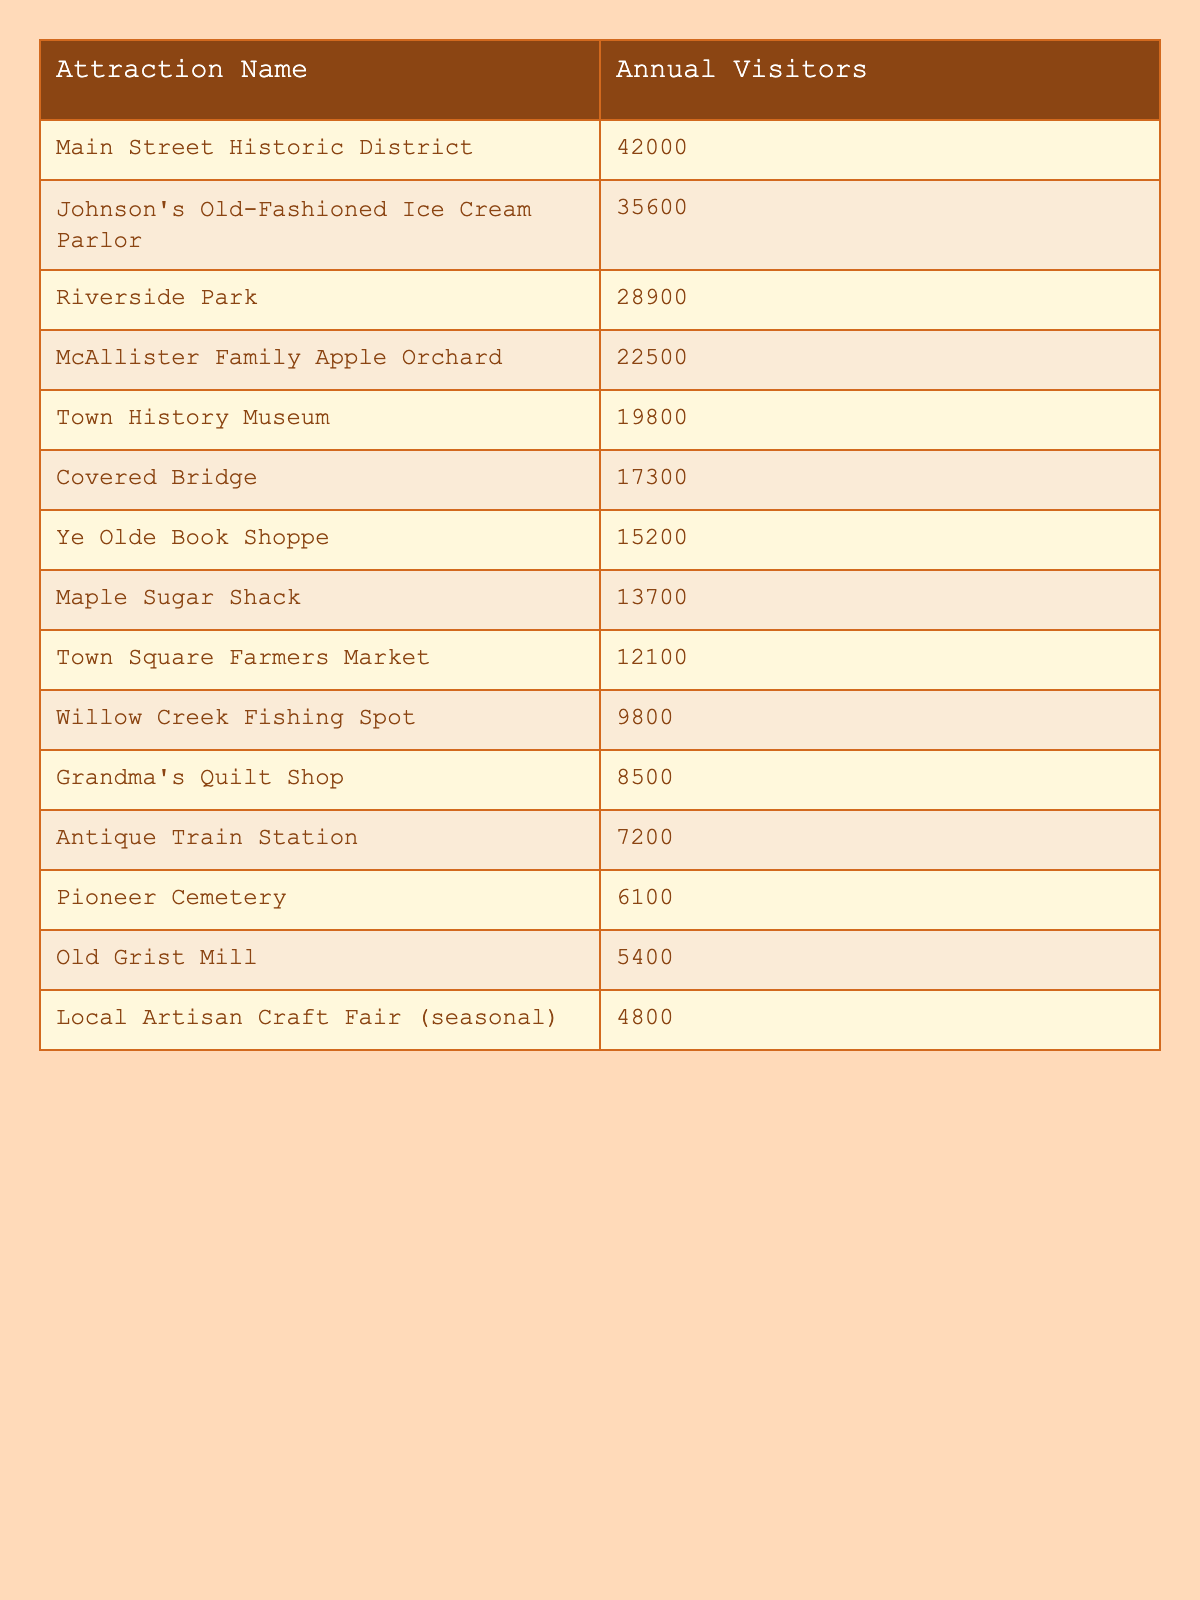What is the attraction with the highest annual visitors? By looking at the table, the "Main Street Historic District" has the highest number of visitors, with 42,000 recorded annually.
Answer: Main Street Historic District How many visitors does the Town History Museum have? The table lists the "Town History Museum" with an annual visitor count of 19,800.
Answer: 19800 What is the total number of visitors for the top three attractions? To find the total, we add the annual visitors of the top three attractions: 42,000 (Main Street) + 35,600 (Johnson's Old-Fashioned Ice Cream Parlor) + 28,900 (Riverside Park) = 113,500.
Answer: 113500 Is the Covered Bridge more popular than Grandma's Quilt Shop? The table shows that the Covered Bridge has 17,300 visitors while Grandma's Quilt Shop has 8,500 visitors, thus the Covered Bridge is more popular.
Answer: Yes What is the difference in visitor counts between the McAllister Family Apple Orchard and the Antique Train Station? The McAllister Family Apple Orchard has 22,500 visitors and the Antique Train Station has 7,200 visitors. The difference is 22,500 - 7,200 = 15,300.
Answer: 15300 What is the average number of visitors for the attractions listed? To find the average, we first sum all the visitor counts (total is 219,700) and then divide by the number of attractions, which is 15. Thus, the average is 219,700 / 15 = 14,646.67, approximately 14,647.
Answer: 14647 Which attraction has fewer than 10,000 visitors? In the table, only the "Willow Creek Fishing Spot," "Grandma's Quilt Shop," "Antique Train Station," "Pioneer Cemetery," "Old Grist Mill," and "Local Artisan Craft Fair (seasonal)" have fewer than 10,000 visitors.
Answer: Yes How many attractions have more than 20,000 annual visitors? According to the table, there are three attractions: Main Street Historic District, Johnson's Old-Fashioned Ice Cream Parlor, and Riverside Park, which have more than 20,000 visitors.
Answer: 3 What is the sum of the annual visitors for the bottom five attractions? The bottom five attractions with their visitors are: 9,800 (Willow Creek), 8,500 (Grandma's Quilt Shop), 7,200 (Antique Train Station), 6,100 (Pioneer Cemetery), and 5,400 (Old Grist Mill). The sum is 9,800 + 8,500 + 7,200 + 6,100 + 5,400 = 37,000.
Answer: 37000 Which attraction ranks second in terms of annual visitors? The "Johnson's Old-Fashioned Ice Cream Parlor" is ranked second in the list with 35,600 annual visitors.
Answer: Johnson's Old-Fashioned Ice Cream Parlor 